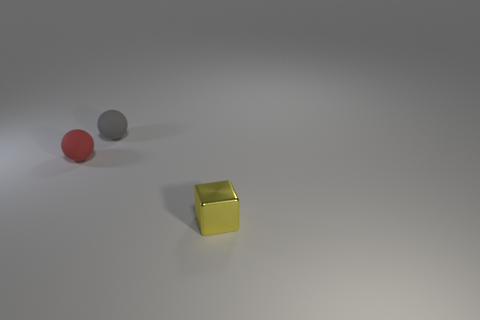Add 1 tiny cubes. How many objects exist? 4 Subtract all spheres. How many objects are left? 1 Add 1 red rubber balls. How many red rubber balls exist? 2 Subtract 0 green balls. How many objects are left? 3 Subtract all large cyan shiny cubes. Subtract all red balls. How many objects are left? 2 Add 3 small objects. How many small objects are left? 6 